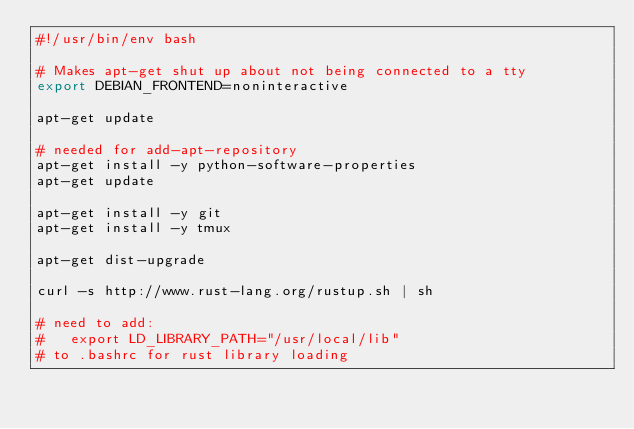Convert code to text. <code><loc_0><loc_0><loc_500><loc_500><_Bash_>#!/usr/bin/env bash

# Makes apt-get shut up about not being connected to a tty
export DEBIAN_FRONTEND=noninteractive

apt-get update

# needed for add-apt-repository
apt-get install -y python-software-properties
apt-get update

apt-get install -y git
apt-get install -y tmux

apt-get dist-upgrade

curl -s http://www.rust-lang.org/rustup.sh | sh

# need to add:
#   export LD_LIBRARY_PATH="/usr/local/lib"
# to .bashrc for rust library loading
</code> 